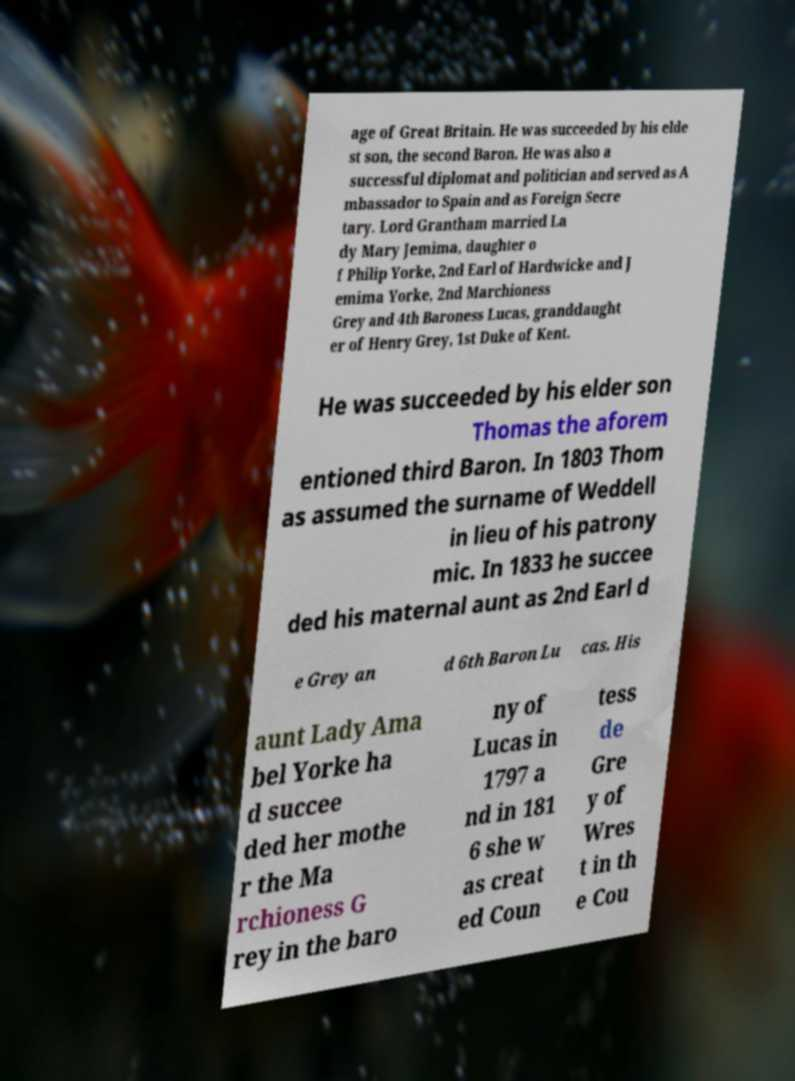What messages or text are displayed in this image? I need them in a readable, typed format. age of Great Britain. He was succeeded by his elde st son, the second Baron. He was also a successful diplomat and politician and served as A mbassador to Spain and as Foreign Secre tary. Lord Grantham married La dy Mary Jemima, daughter o f Philip Yorke, 2nd Earl of Hardwicke and J emima Yorke, 2nd Marchioness Grey and 4th Baroness Lucas, granddaught er of Henry Grey, 1st Duke of Kent. He was succeeded by his elder son Thomas the aforem entioned third Baron. In 1803 Thom as assumed the surname of Weddell in lieu of his patrony mic. In 1833 he succee ded his maternal aunt as 2nd Earl d e Grey an d 6th Baron Lu cas. His aunt Lady Ama bel Yorke ha d succee ded her mothe r the Ma rchioness G rey in the baro ny of Lucas in 1797 a nd in 181 6 she w as creat ed Coun tess de Gre y of Wres t in th e Cou 